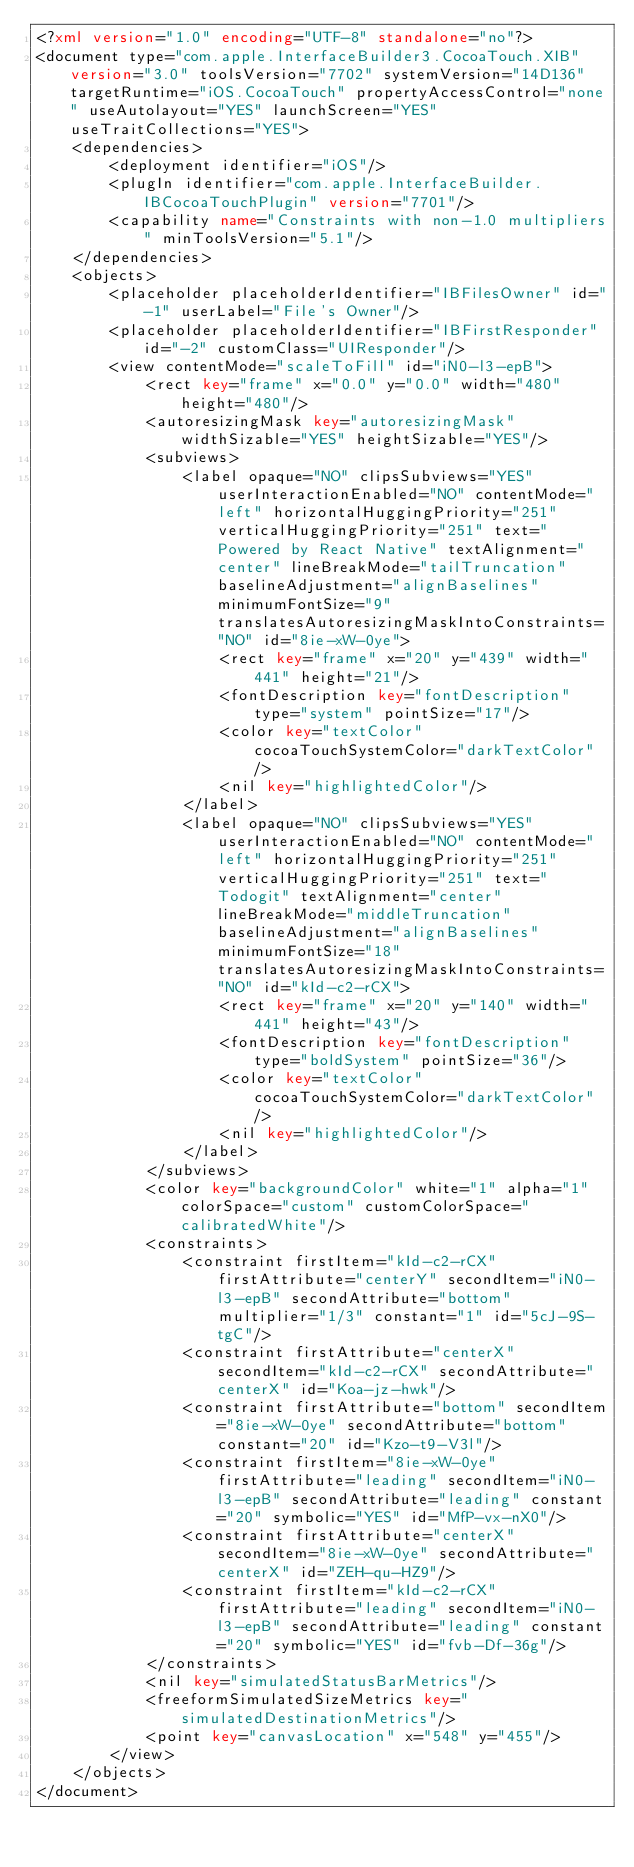Convert code to text. <code><loc_0><loc_0><loc_500><loc_500><_XML_><?xml version="1.0" encoding="UTF-8" standalone="no"?>
<document type="com.apple.InterfaceBuilder3.CocoaTouch.XIB" version="3.0" toolsVersion="7702" systemVersion="14D136" targetRuntime="iOS.CocoaTouch" propertyAccessControl="none" useAutolayout="YES" launchScreen="YES" useTraitCollections="YES">
    <dependencies>
        <deployment identifier="iOS"/>
        <plugIn identifier="com.apple.InterfaceBuilder.IBCocoaTouchPlugin" version="7701"/>
        <capability name="Constraints with non-1.0 multipliers" minToolsVersion="5.1"/>
    </dependencies>
    <objects>
        <placeholder placeholderIdentifier="IBFilesOwner" id="-1" userLabel="File's Owner"/>
        <placeholder placeholderIdentifier="IBFirstResponder" id="-2" customClass="UIResponder"/>
        <view contentMode="scaleToFill" id="iN0-l3-epB">
            <rect key="frame" x="0.0" y="0.0" width="480" height="480"/>
            <autoresizingMask key="autoresizingMask" widthSizable="YES" heightSizable="YES"/>
            <subviews>
                <label opaque="NO" clipsSubviews="YES" userInteractionEnabled="NO" contentMode="left" horizontalHuggingPriority="251" verticalHuggingPriority="251" text="Powered by React Native" textAlignment="center" lineBreakMode="tailTruncation" baselineAdjustment="alignBaselines" minimumFontSize="9" translatesAutoresizingMaskIntoConstraints="NO" id="8ie-xW-0ye">
                    <rect key="frame" x="20" y="439" width="441" height="21"/>
                    <fontDescription key="fontDescription" type="system" pointSize="17"/>
                    <color key="textColor" cocoaTouchSystemColor="darkTextColor"/>
                    <nil key="highlightedColor"/>
                </label>
                <label opaque="NO" clipsSubviews="YES" userInteractionEnabled="NO" contentMode="left" horizontalHuggingPriority="251" verticalHuggingPriority="251" text="Todogit" textAlignment="center" lineBreakMode="middleTruncation" baselineAdjustment="alignBaselines" minimumFontSize="18" translatesAutoresizingMaskIntoConstraints="NO" id="kId-c2-rCX">
                    <rect key="frame" x="20" y="140" width="441" height="43"/>
                    <fontDescription key="fontDescription" type="boldSystem" pointSize="36"/>
                    <color key="textColor" cocoaTouchSystemColor="darkTextColor"/>
                    <nil key="highlightedColor"/>
                </label>
            </subviews>
            <color key="backgroundColor" white="1" alpha="1" colorSpace="custom" customColorSpace="calibratedWhite"/>
            <constraints>
                <constraint firstItem="kId-c2-rCX" firstAttribute="centerY" secondItem="iN0-l3-epB" secondAttribute="bottom" multiplier="1/3" constant="1" id="5cJ-9S-tgC"/>
                <constraint firstAttribute="centerX" secondItem="kId-c2-rCX" secondAttribute="centerX" id="Koa-jz-hwk"/>
                <constraint firstAttribute="bottom" secondItem="8ie-xW-0ye" secondAttribute="bottom" constant="20" id="Kzo-t9-V3l"/>
                <constraint firstItem="8ie-xW-0ye" firstAttribute="leading" secondItem="iN0-l3-epB" secondAttribute="leading" constant="20" symbolic="YES" id="MfP-vx-nX0"/>
                <constraint firstAttribute="centerX" secondItem="8ie-xW-0ye" secondAttribute="centerX" id="ZEH-qu-HZ9"/>
                <constraint firstItem="kId-c2-rCX" firstAttribute="leading" secondItem="iN0-l3-epB" secondAttribute="leading" constant="20" symbolic="YES" id="fvb-Df-36g"/>
            </constraints>
            <nil key="simulatedStatusBarMetrics"/>
            <freeformSimulatedSizeMetrics key="simulatedDestinationMetrics"/>
            <point key="canvasLocation" x="548" y="455"/>
        </view>
    </objects>
</document>
</code> 